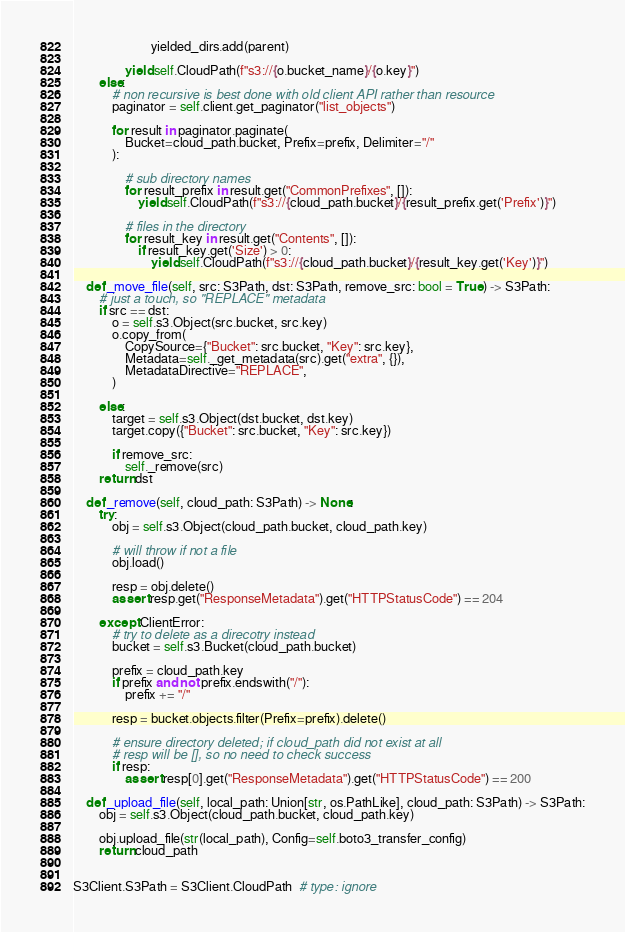<code> <loc_0><loc_0><loc_500><loc_500><_Python_>                        yielded_dirs.add(parent)

                yield self.CloudPath(f"s3://{o.bucket_name}/{o.key}")
        else:
            # non recursive is best done with old client API rather than resource
            paginator = self.client.get_paginator("list_objects")

            for result in paginator.paginate(
                Bucket=cloud_path.bucket, Prefix=prefix, Delimiter="/"
            ):

                # sub directory names
                for result_prefix in result.get("CommonPrefixes", []):
                    yield self.CloudPath(f"s3://{cloud_path.bucket}/{result_prefix.get('Prefix')}")

                # files in the directory
                for result_key in result.get("Contents", []):
                    if result_key.get('Size') > 0:
                        yield self.CloudPath(f"s3://{cloud_path.bucket}/{result_key.get('Key')}")

    def _move_file(self, src: S3Path, dst: S3Path, remove_src: bool = True) -> S3Path:
        # just a touch, so "REPLACE" metadata
        if src == dst:
            o = self.s3.Object(src.bucket, src.key)
            o.copy_from(
                CopySource={"Bucket": src.bucket, "Key": src.key},
                Metadata=self._get_metadata(src).get("extra", {}),
                MetadataDirective="REPLACE",
            )

        else:
            target = self.s3.Object(dst.bucket, dst.key)
            target.copy({"Bucket": src.bucket, "Key": src.key})

            if remove_src:
                self._remove(src)
        return dst

    def _remove(self, cloud_path: S3Path) -> None:
        try:
            obj = self.s3.Object(cloud_path.bucket, cloud_path.key)

            # will throw if not a file
            obj.load()

            resp = obj.delete()
            assert resp.get("ResponseMetadata").get("HTTPStatusCode") == 204

        except ClientError:
            # try to delete as a direcotry instead
            bucket = self.s3.Bucket(cloud_path.bucket)

            prefix = cloud_path.key
            if prefix and not prefix.endswith("/"):
                prefix += "/"

            resp = bucket.objects.filter(Prefix=prefix).delete()

            # ensure directory deleted; if cloud_path did not exist at all
            # resp will be [], so no need to check success
            if resp:
                assert resp[0].get("ResponseMetadata").get("HTTPStatusCode") == 200

    def _upload_file(self, local_path: Union[str, os.PathLike], cloud_path: S3Path) -> S3Path:
        obj = self.s3.Object(cloud_path.bucket, cloud_path.key)

        obj.upload_file(str(local_path), Config=self.boto3_transfer_config)
        return cloud_path


S3Client.S3Path = S3Client.CloudPath  # type: ignore
</code> 